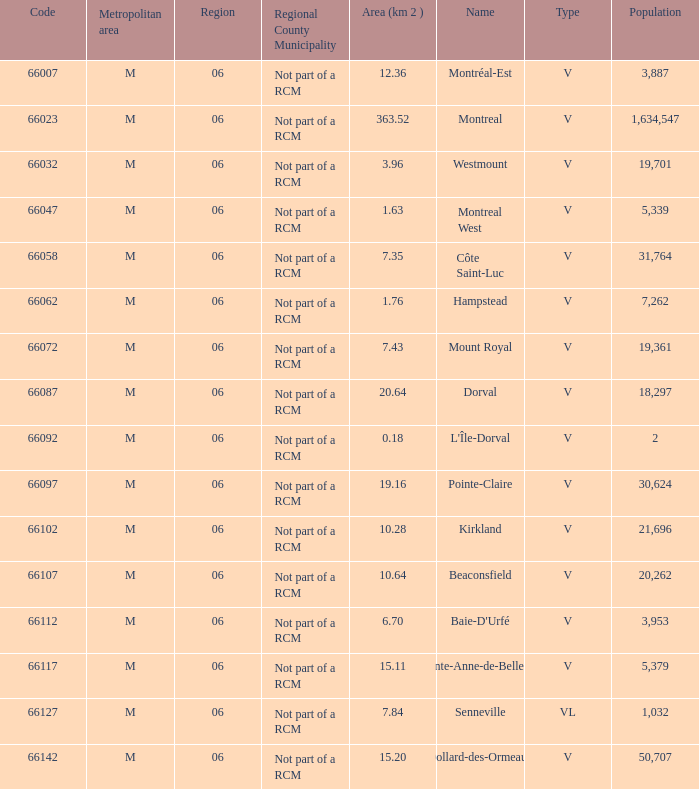What is the largest area with a Code of 66097, and a Region larger than 6? None. 